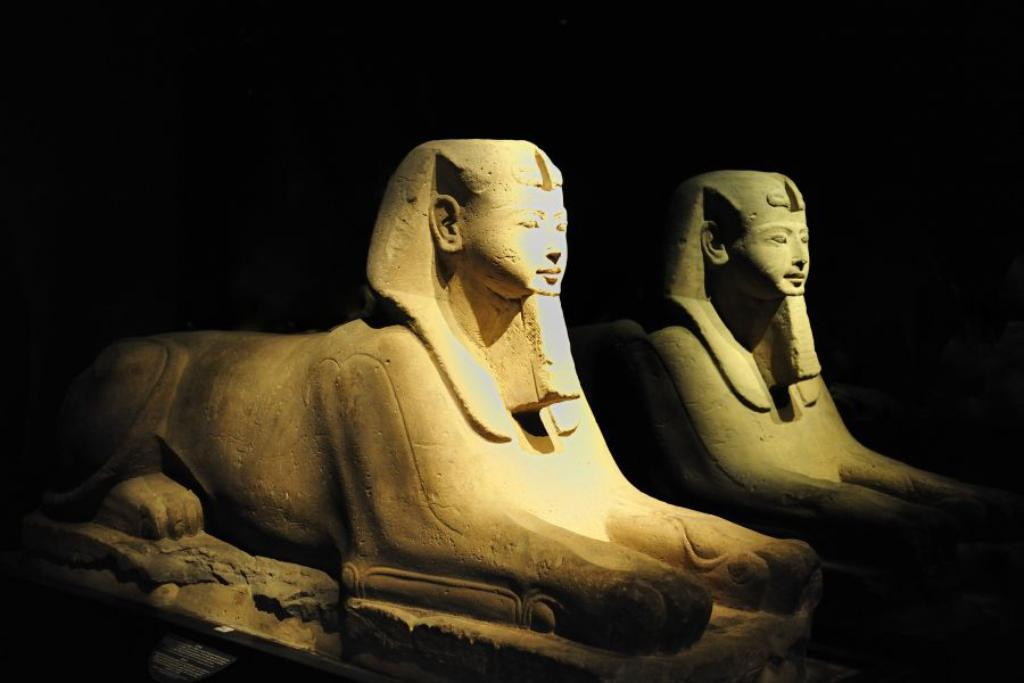What can be seen in the image? There are statues in the image. What is the color of the background in the image? The background of the image is dark. How does the kitten provide comfort to the statues in the image? There is no kitten present in the image, so it cannot provide comfort to the statues. 